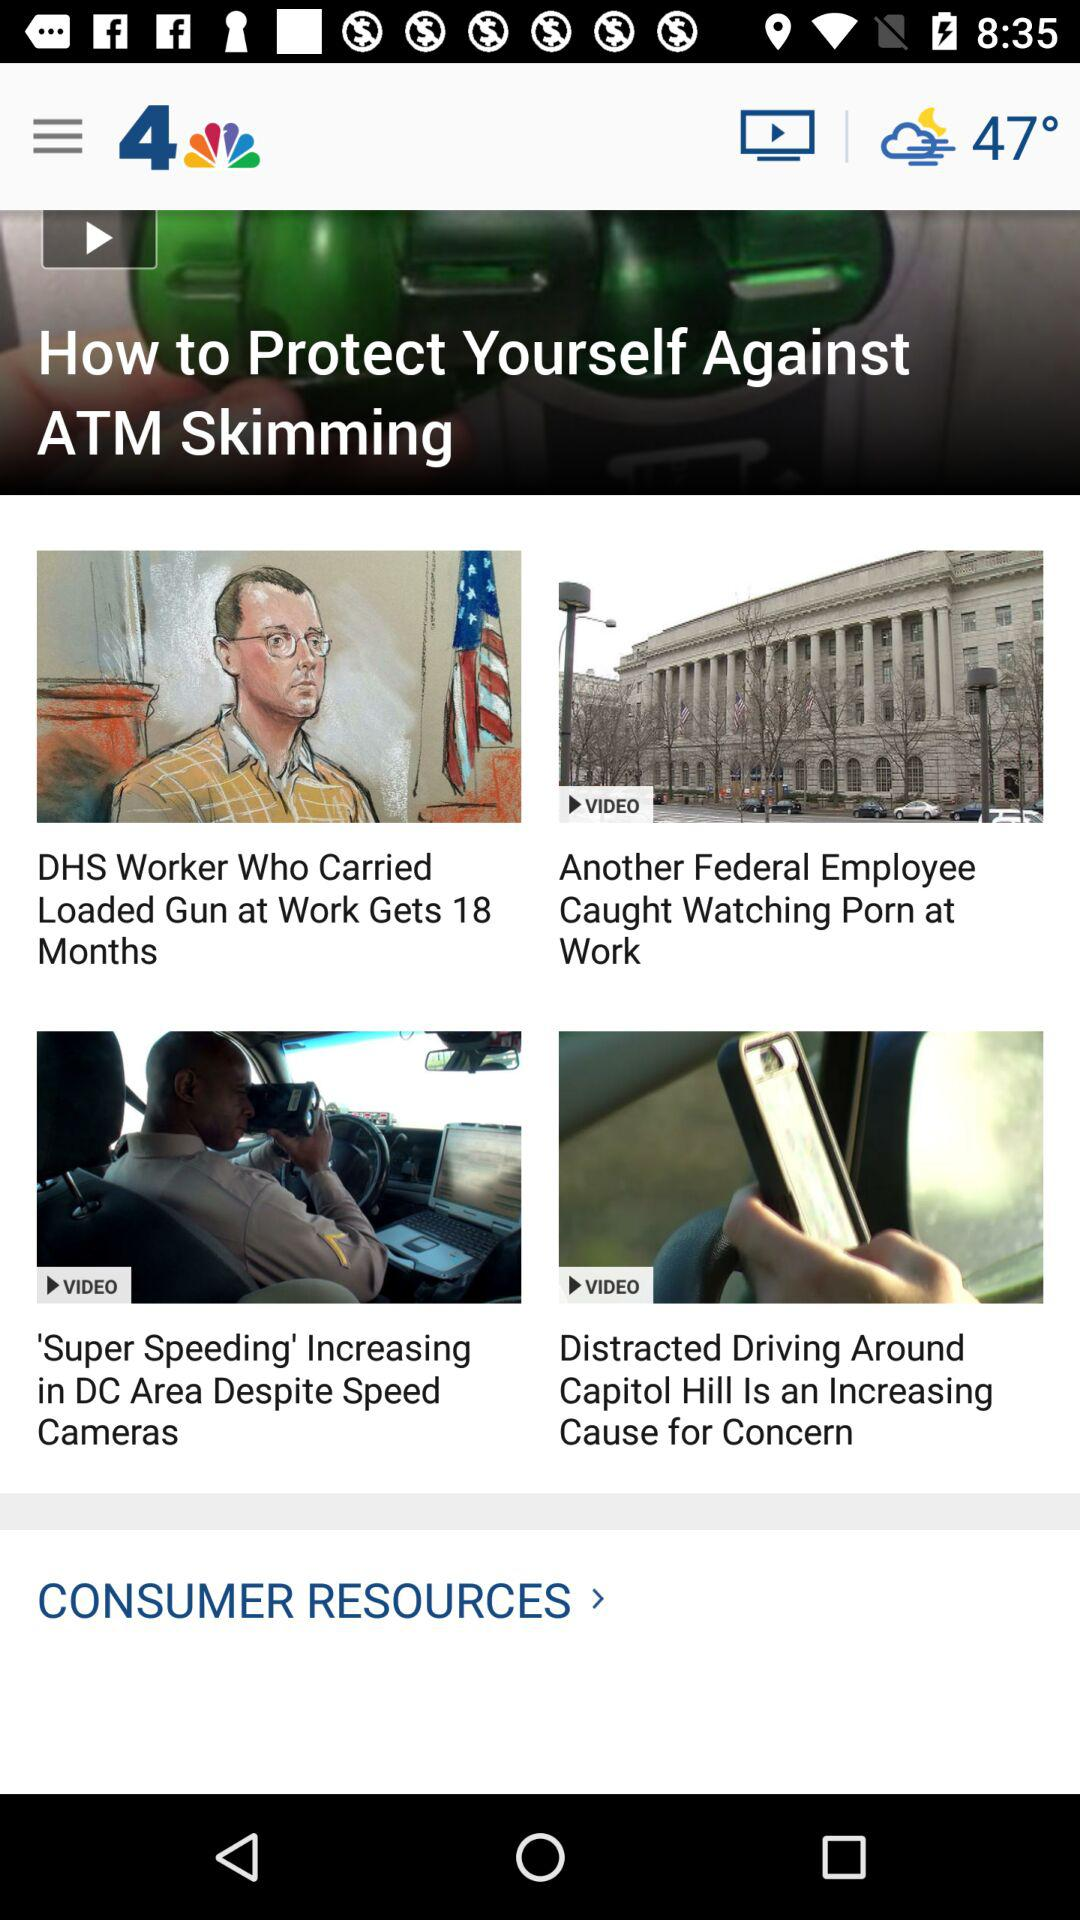How many more videos are there about the capitol building than videos about speeding?
Answer the question using a single word or phrase. 1 